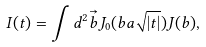Convert formula to latex. <formula><loc_0><loc_0><loc_500><loc_500>I ( t ) = \int d ^ { 2 } \vec { b } J _ { 0 } ( b a \sqrt { | t | } ) J ( b ) ,</formula> 